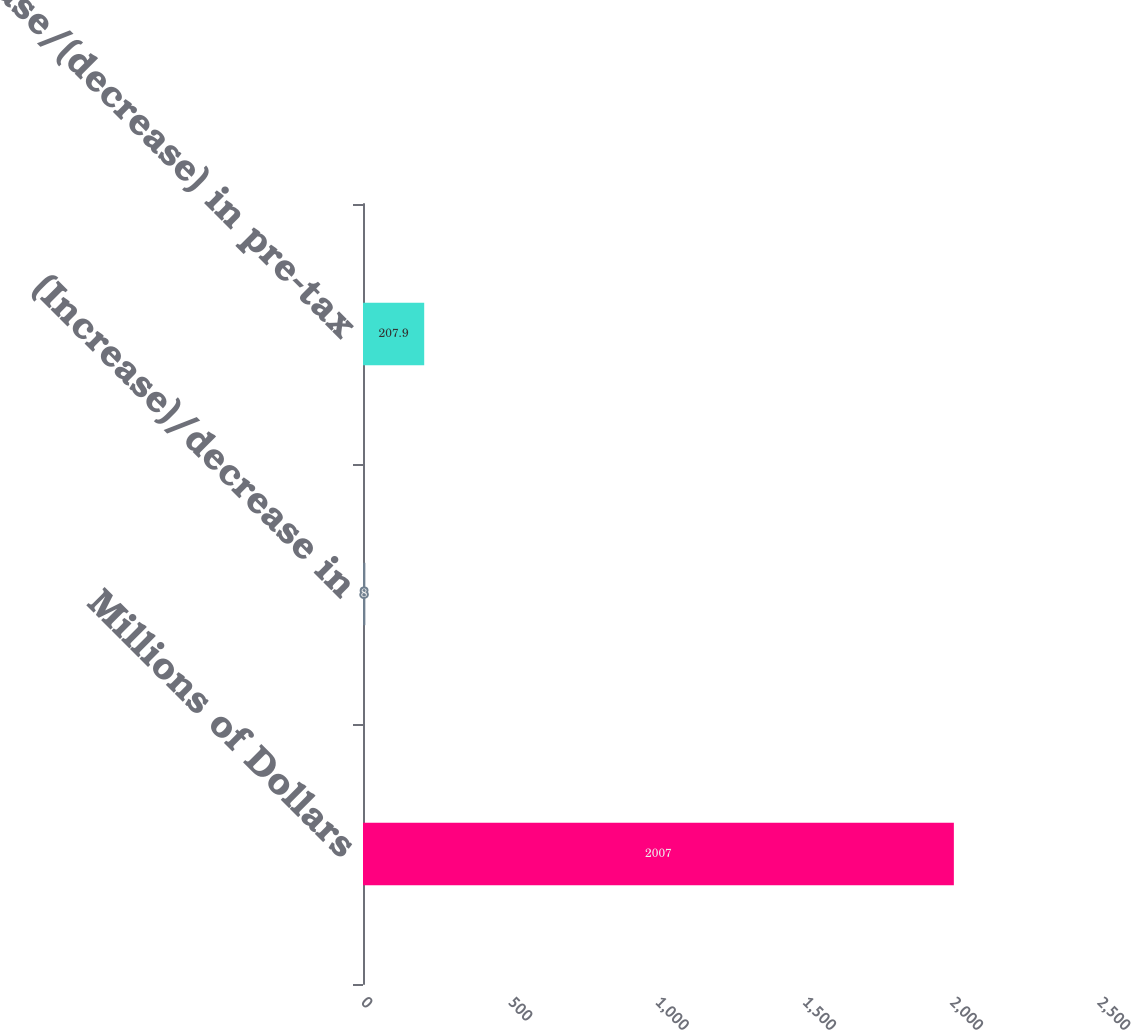Convert chart to OTSL. <chart><loc_0><loc_0><loc_500><loc_500><bar_chart><fcel>Millions of Dollars<fcel>(Increase)/decrease in<fcel>Increase/(decrease) in pre-tax<nl><fcel>2007<fcel>8<fcel>207.9<nl></chart> 